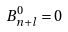<formula> <loc_0><loc_0><loc_500><loc_500>B _ { n + l } ^ { 0 } = 0</formula> 